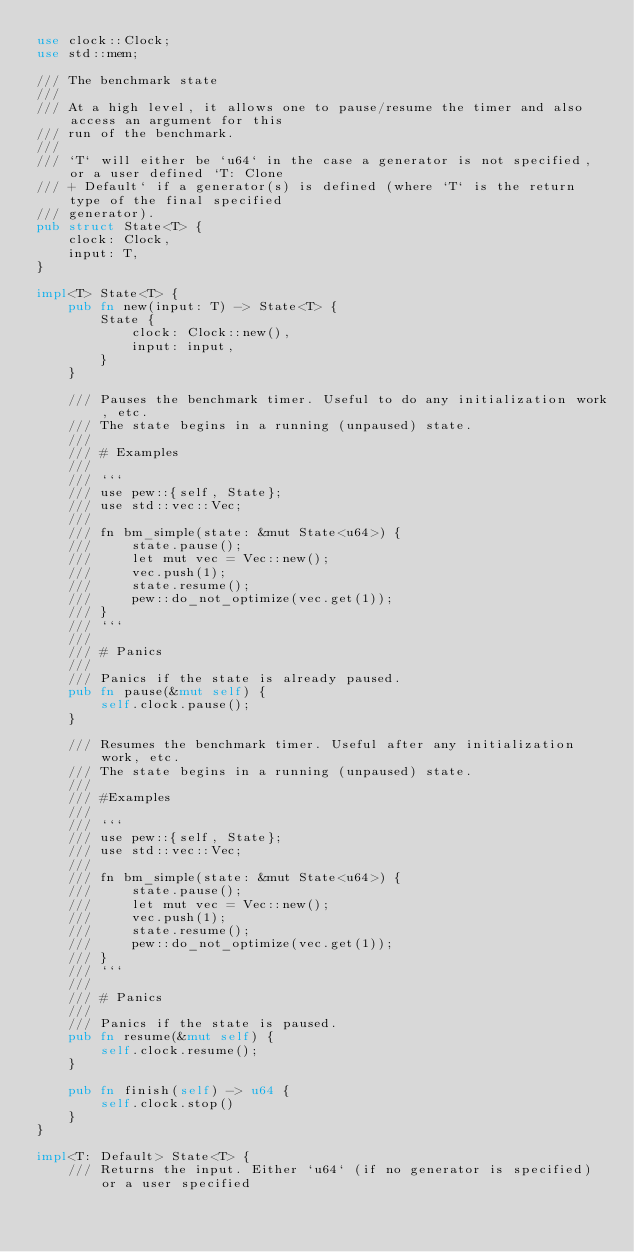Convert code to text. <code><loc_0><loc_0><loc_500><loc_500><_Rust_>use clock::Clock;
use std::mem;

/// The benchmark state
///
/// At a high level, it allows one to pause/resume the timer and also access an argument for this
/// run of the benchmark.
///
/// `T` will either be `u64` in the case a generator is not specified, or a user defined `T: Clone
/// + Default` if a generator(s) is defined (where `T` is the return type of the final specified
/// generator).
pub struct State<T> {
    clock: Clock,
    input: T,
}

impl<T> State<T> {
    pub fn new(input: T) -> State<T> {
        State {
            clock: Clock::new(),
            input: input,
        }
    }

    /// Pauses the benchmark timer. Useful to do any initialization work, etc.
    /// The state begins in a running (unpaused) state.
    ///
    /// # Examples
    ///
    /// ```
    /// use pew::{self, State};
    /// use std::vec::Vec;
    ///
    /// fn bm_simple(state: &mut State<u64>) {
    ///     state.pause();
    ///     let mut vec = Vec::new();
    ///     vec.push(1);
    ///     state.resume();
    ///     pew::do_not_optimize(vec.get(1));
    /// }
    /// ```
    ///
    /// # Panics
    ///
    /// Panics if the state is already paused.
    pub fn pause(&mut self) {
        self.clock.pause();
    }

    /// Resumes the benchmark timer. Useful after any initialization work, etc.
    /// The state begins in a running (unpaused) state.
    ///
    /// #Examples
    ///
    /// ```
    /// use pew::{self, State};
    /// use std::vec::Vec;
    ///
    /// fn bm_simple(state: &mut State<u64>) {
    ///     state.pause();
    ///     let mut vec = Vec::new();
    ///     vec.push(1);
    ///     state.resume();
    ///     pew::do_not_optimize(vec.get(1));
    /// }
    /// ```
    ///
    /// # Panics
    ///
    /// Panics if the state is paused.
    pub fn resume(&mut self) {
        self.clock.resume();
    }

    pub fn finish(self) -> u64 {
        self.clock.stop()
    }
}

impl<T: Default> State<T> {
    /// Returns the input. Either `u64` (if no generator is specified) or a user specified</code> 